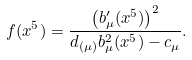Convert formula to latex. <formula><loc_0><loc_0><loc_500><loc_500>f ( x ^ { 5 } ) = \frac { \left ( b _ { \mu } ^ { \prime } ( x ^ { 5 } ) \right ) ^ { 2 } } { d _ { \left ( \mu \right ) } b _ { \mu } ^ { 2 } ( x ^ { 5 } ) - c _ { \mu } } .</formula> 